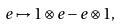Convert formula to latex. <formula><loc_0><loc_0><loc_500><loc_500>e \mapsto 1 \otimes e - e \otimes 1 ,</formula> 